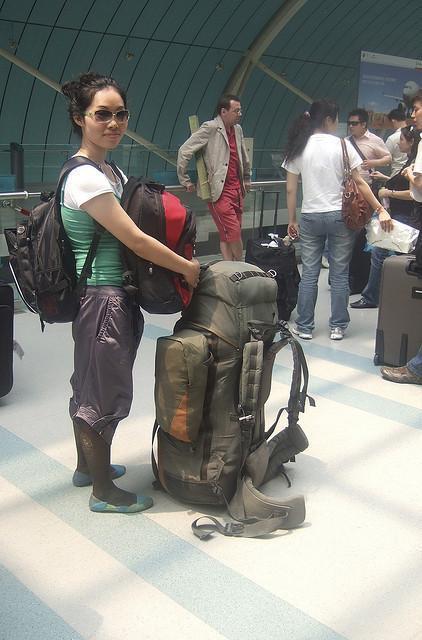How many backpacks are there?
Give a very brief answer. 3. How many people are there?
Give a very brief answer. 3. How many suitcases are in the photo?
Give a very brief answer. 2. 